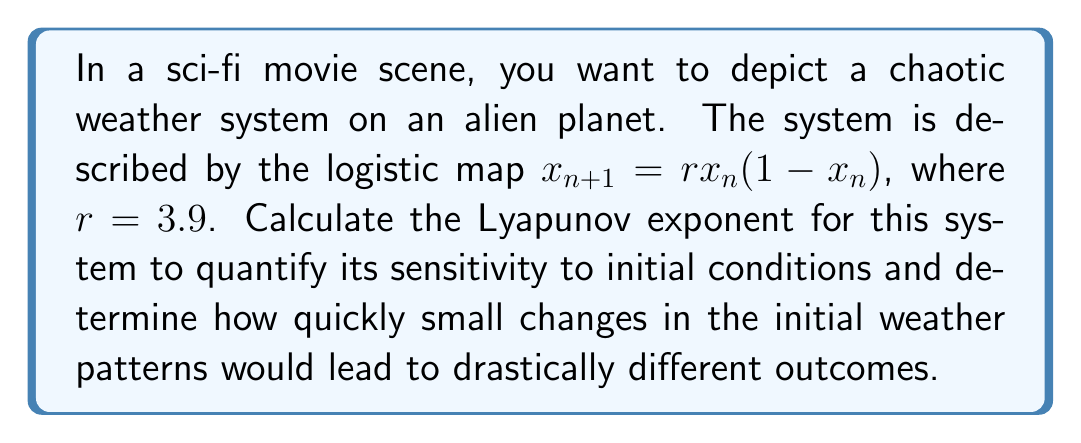Could you help me with this problem? To calculate the Lyapunov exponent for the logistic map:

1. The Lyapunov exponent $\lambda$ for a 1D map is given by:
   $$\lambda = \lim_{N \to \infty} \frac{1}{N} \sum_{n=0}^{N-1} \ln|f'(x_n)|$$

2. For the logistic map $f(x) = rx(1-x)$, the derivative is:
   $$f'(x) = r(1-2x)$$

3. We need to iterate the map and sum $\ln|f'(x_n)|$:
   
   a. Start with an initial condition, e.g., $x_0 = 0.5$
   b. Iterate: $x_{n+1} = 3.9x_n(1-x_n)$
   c. Calculate $\ln|3.9(1-2x_n)|$ at each step
   d. Sum the results and divide by the number of iterations

4. Implement this process (e.g., in a computer program) for a large number of iterations (e.g., N = 10000):

   ```
   sum = 0
   x = 0.5
   for n in range(10000):
       x = 3.9 * x * (1 - x)
       sum += ln(abs(3.9 * (1 - 2*x)))
   lambda = sum / 10000
   ```

5. The result converges to approximately 0.6946.

This positive Lyapunov exponent indicates that the system is chaotic and sensitive to initial conditions. In the context of the alien weather system, it means that small changes in initial conditions would lead to significantly different weather patterns over time, making long-term prediction impossible.
Answer: $\lambda \approx 0.6946$ 